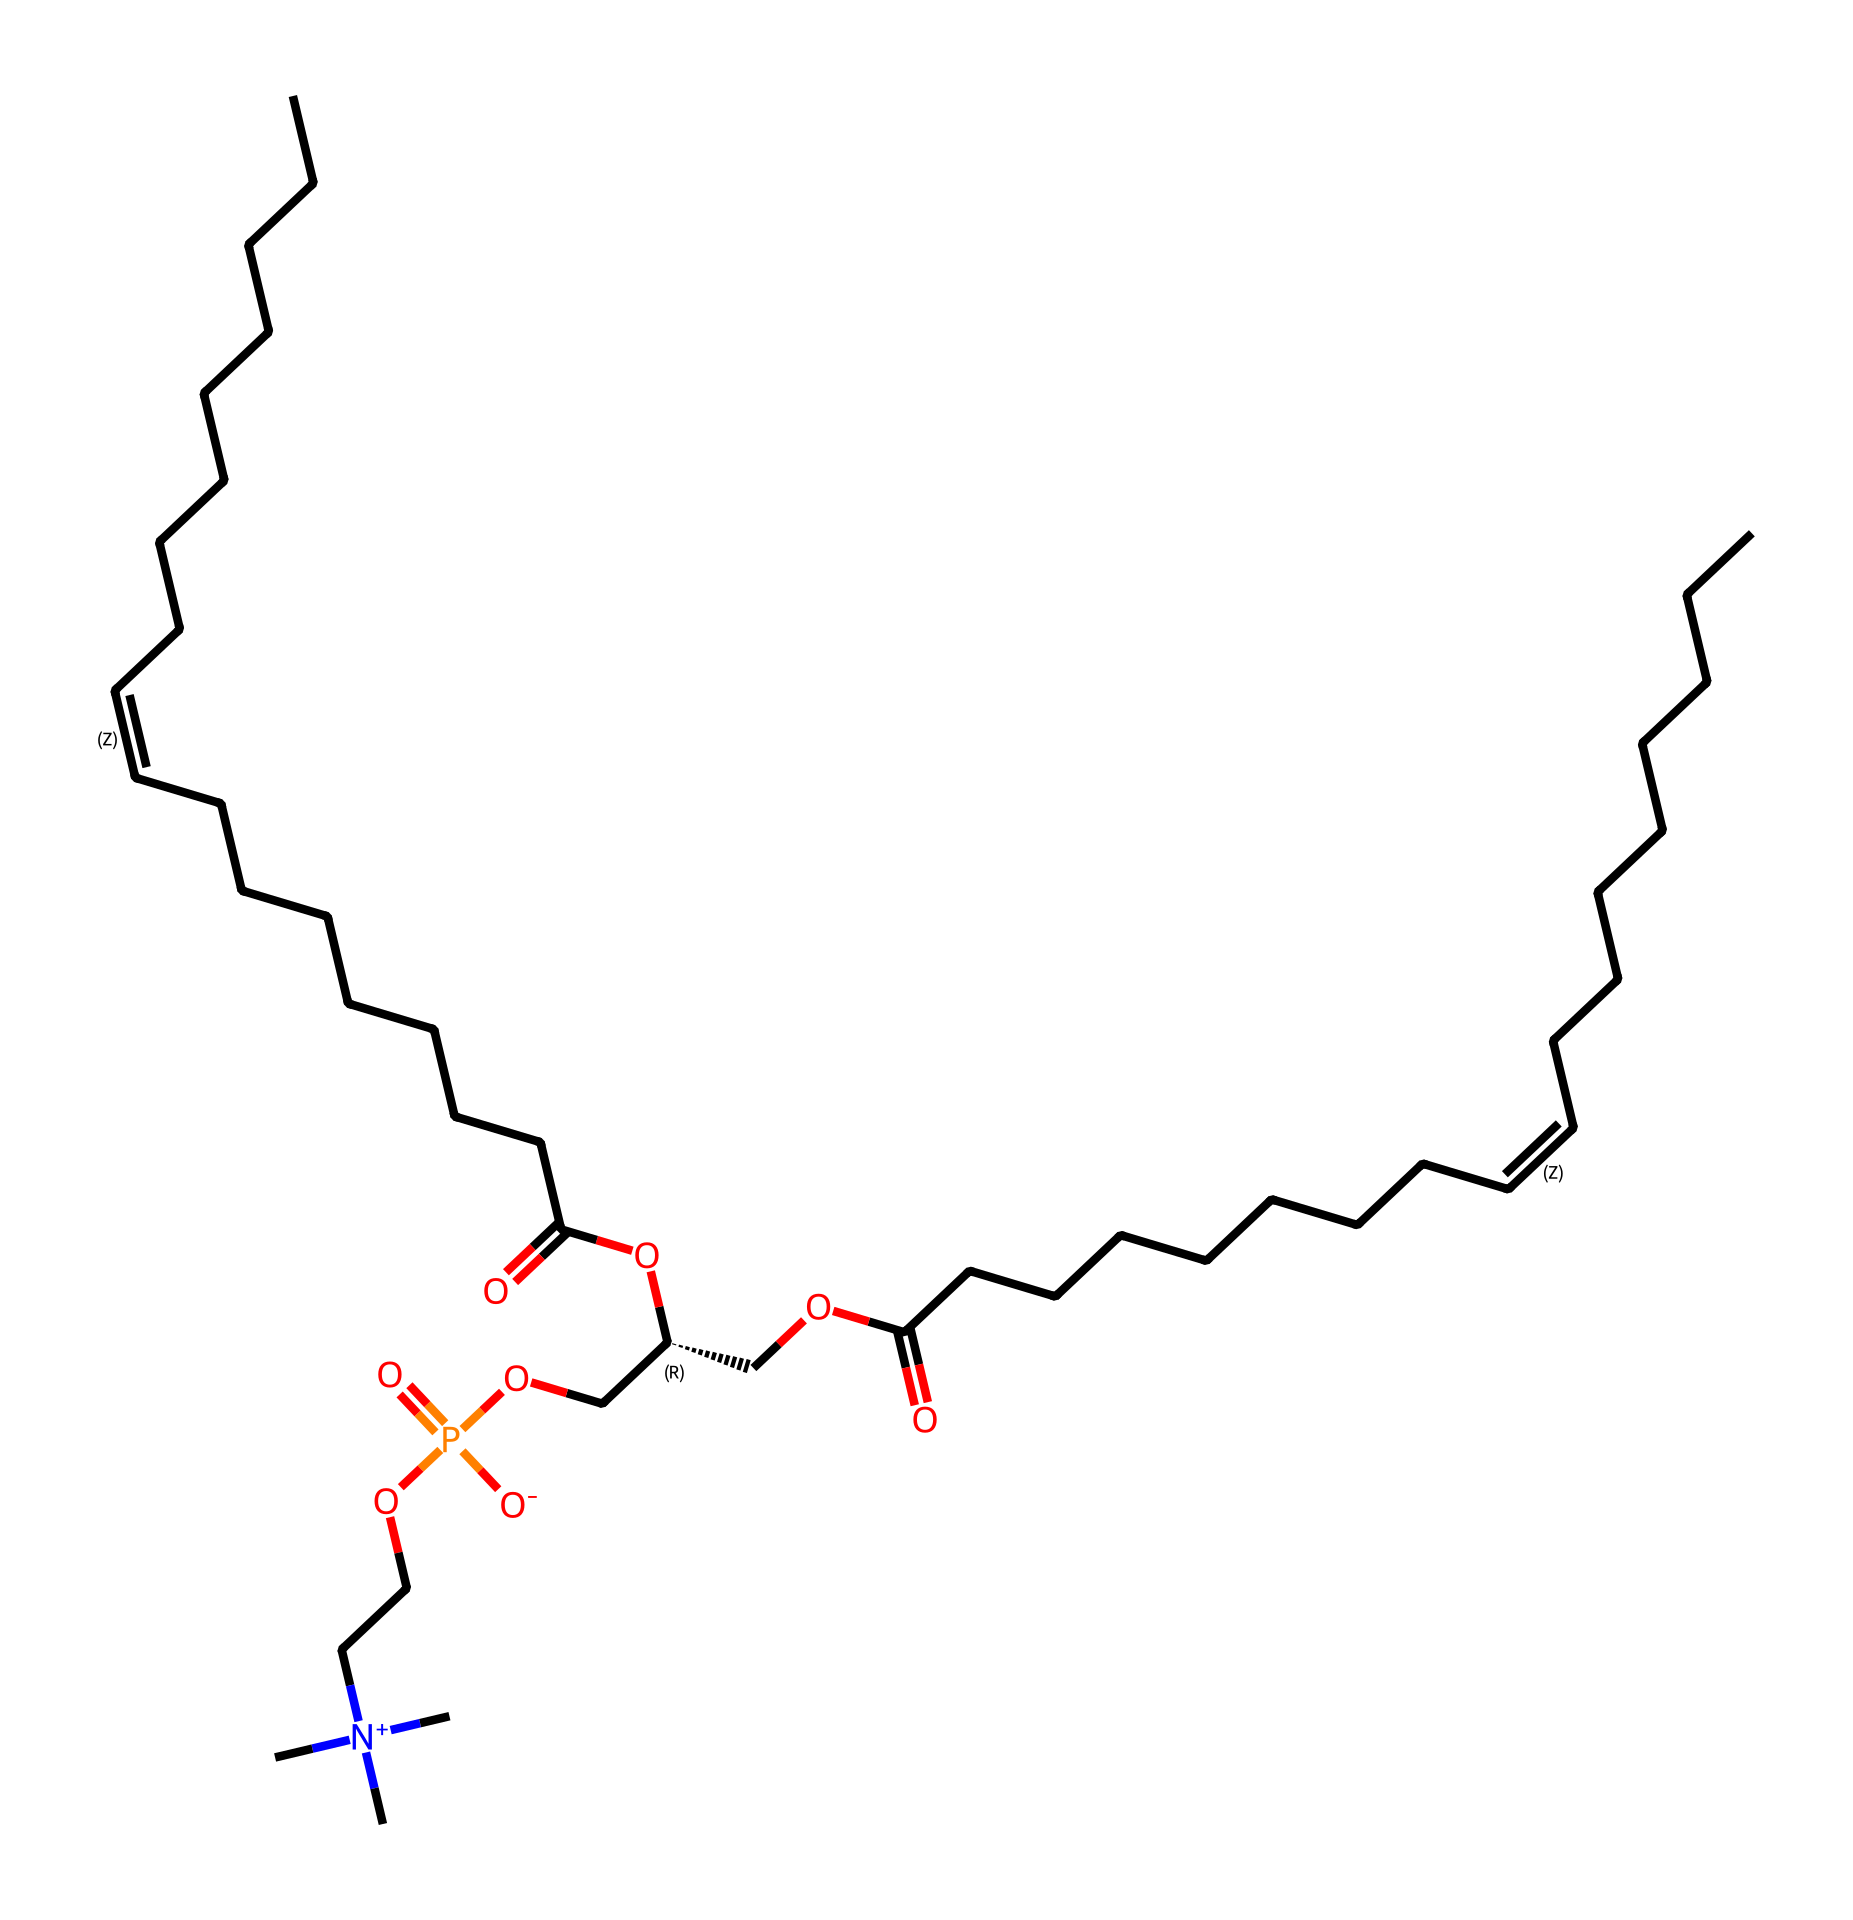What is the main functional group present in this molecule? The molecule contains ester groups, indicated by the carbonyl (C=O) and oxygen (O) connection. Esters are characterized by the presence of a -COO- structure.
Answer: ester How many carbon atoms are there in the longest hydrocarbon chain? By analyzing the chemical structure, the longest hydrocarbon chain is identified as the continuous series of carbon atoms, which in this case counts to 18.
Answer: 18 What type of chemical reaction can be inferred from the presence of the phosphate group? The phosphate group suggests a phosphorylation reaction, which typically involves the addition of a phosphate group to a molecule, indicating potential energy transfer or signal transduction mechanisms.
Answer: phosphorylation What specific characteristic of nanoemulsions can be attributed to the presence of surfactants in this molecule? The presence of surfactants, such as the moieties with a hydrophilic character (like the phosphate-containing group), enables the stabilization of emulsions by reducing surface tension at the oil-water interface.
Answer: stabilization What is the significance of the unsaturation (C=C) in this molecular structure? The unsaturation provides the molecule with reactive double bonds, allowing for cross-linking and enhancing the texture and mouthfeel of food products through potential polymerization reactions.
Answer: enhance texture How does the presence of quaternary ammonium groups affect the properties of this emulsion? Quaternary ammonium groups contribute positive charges, which enhance the emulsifying properties through increased stability against coalescence, improving long-term shelf-life and texture in food products.
Answer: enhance stability 